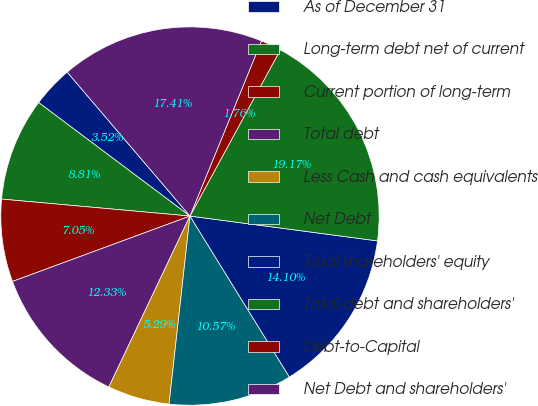<chart> <loc_0><loc_0><loc_500><loc_500><pie_chart><fcel>As of December 31<fcel>Long-term debt net of current<fcel>Current portion of long-term<fcel>Total debt<fcel>Less Cash and cash equivalents<fcel>Net Debt<fcel>Total shareholders' equity<fcel>Total debt and shareholders'<fcel>Debt-to-Capital<fcel>Net Debt and shareholders'<nl><fcel>3.52%<fcel>8.81%<fcel>7.05%<fcel>12.33%<fcel>5.29%<fcel>10.57%<fcel>14.1%<fcel>19.17%<fcel>1.76%<fcel>17.41%<nl></chart> 